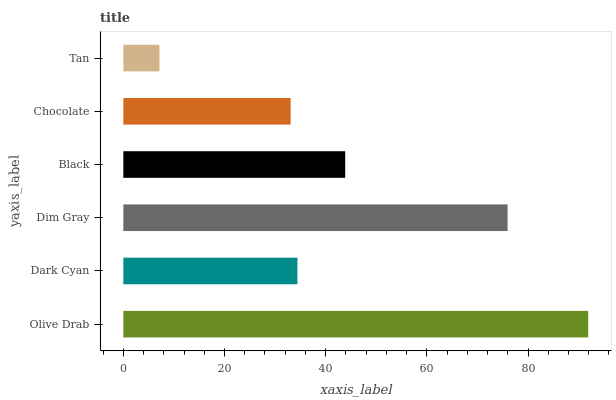Is Tan the minimum?
Answer yes or no. Yes. Is Olive Drab the maximum?
Answer yes or no. Yes. Is Dark Cyan the minimum?
Answer yes or no. No. Is Dark Cyan the maximum?
Answer yes or no. No. Is Olive Drab greater than Dark Cyan?
Answer yes or no. Yes. Is Dark Cyan less than Olive Drab?
Answer yes or no. Yes. Is Dark Cyan greater than Olive Drab?
Answer yes or no. No. Is Olive Drab less than Dark Cyan?
Answer yes or no. No. Is Black the high median?
Answer yes or no. Yes. Is Dark Cyan the low median?
Answer yes or no. Yes. Is Dim Gray the high median?
Answer yes or no. No. Is Chocolate the low median?
Answer yes or no. No. 